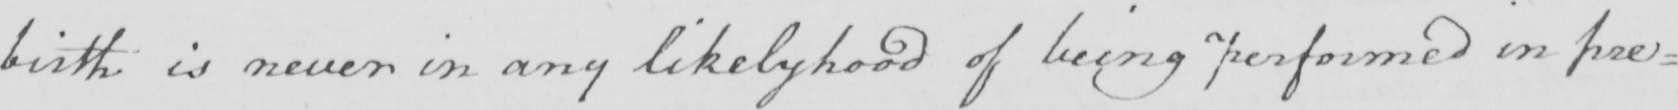Please provide the text content of this handwritten line. birth is never in any likelyhood of being performed in pre= 